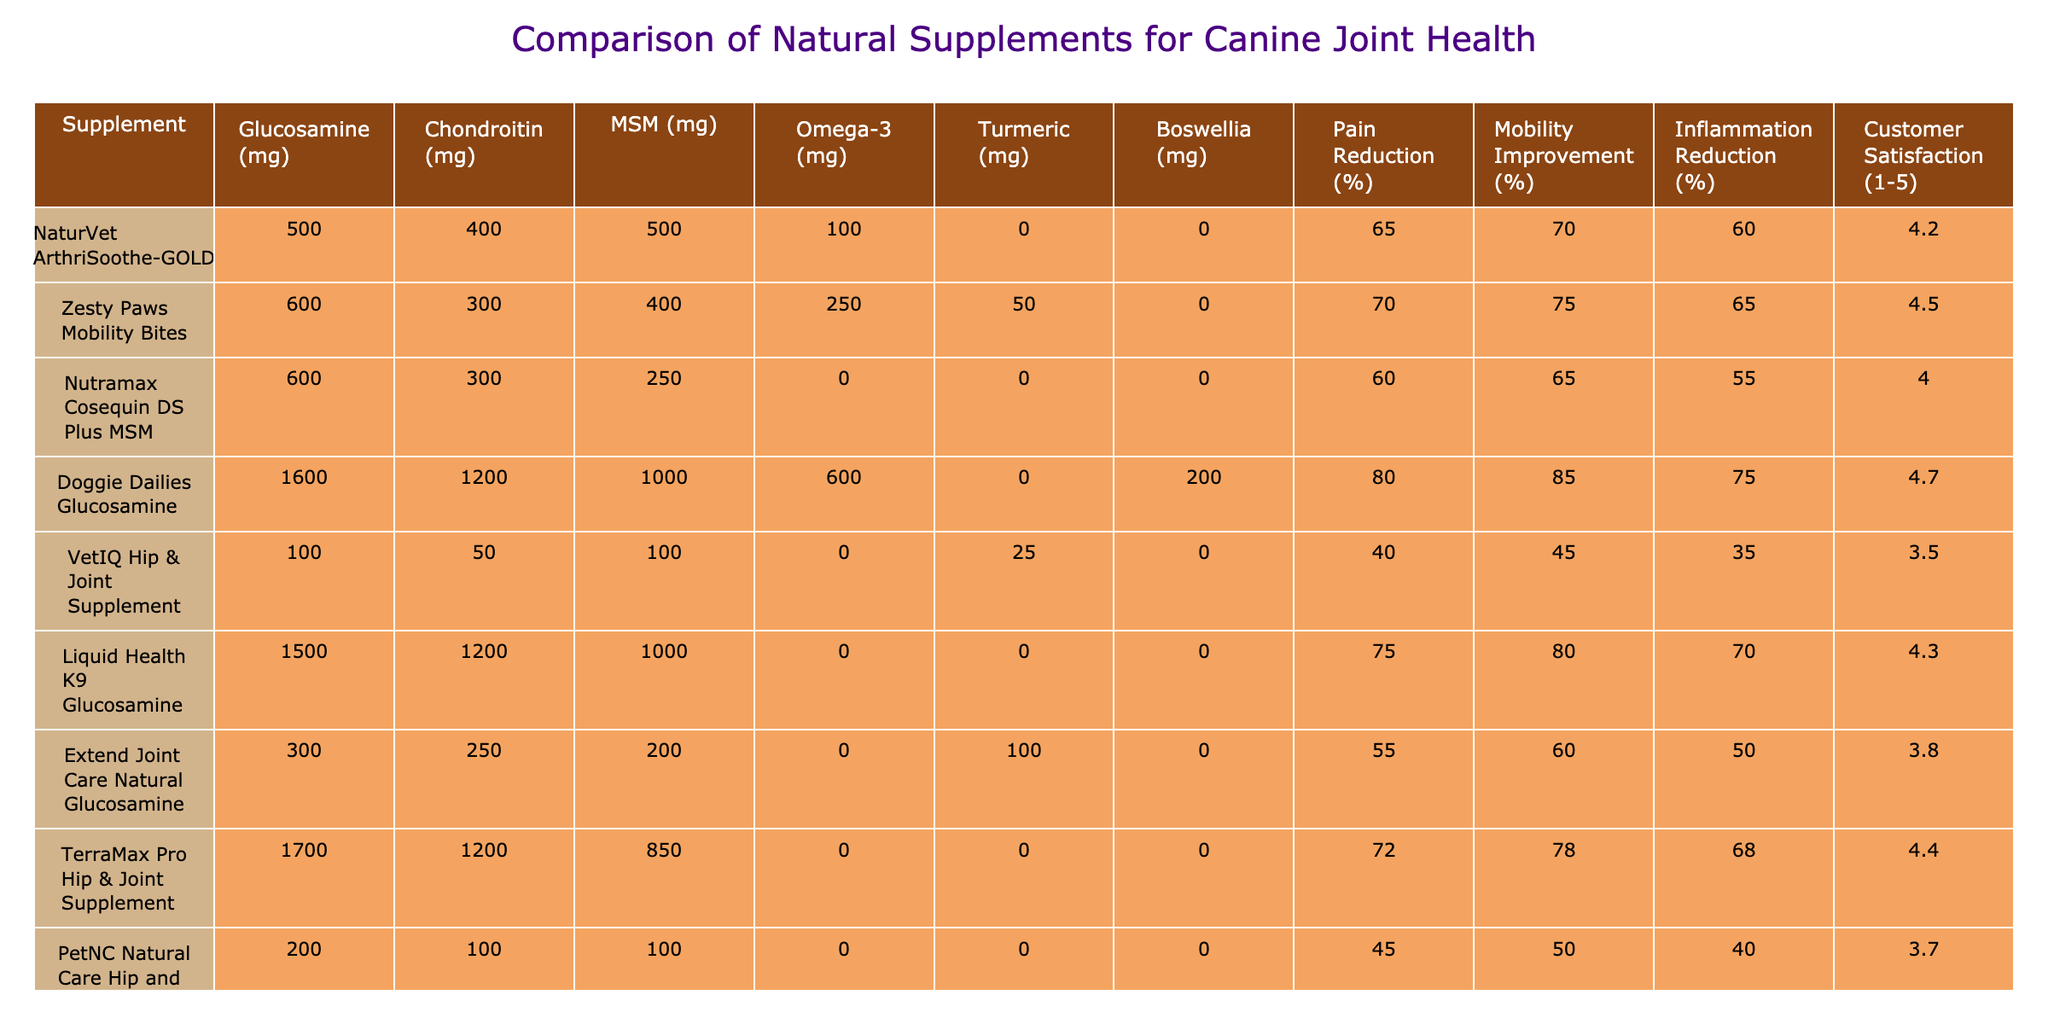What is the customer satisfaction score for Doggie Dailies Glucosamine? The table lists Doggie Dailies Glucosamine under the supplements, with its corresponding customer satisfaction score found in the last column. The score is 4.7.
Answer: 4.7 Which supplement has the highest pain reduction percentage? Looking at the Pain Reduction percentage column, Doggie Dailies Glucosamine has the highest percentage at 80%.
Answer: 80% What is the total dosage of Omega-3 for Zesty Paws Mobility Bites and Infinite Pet Supplements All-Natural Hip & Joint Supplement combined? Zesty Paws Mobility Bites has an Omega-3 dosage of 250 mg, and Infinite Pet Supplements has 300 mg. Adding them together gives 250 + 300 = 550 mg.
Answer: 550 mg Is it true that VetIQ Hip & Joint Supplement has more Chondroitin than NaturVet ArthriSoothe-GOLD? Evaluating the values in the Chondroitin column, VetIQ Hip & Joint Supplement contains 50 mg while NaturVet ArthriSoothe-GOLD has 400 mg, making the statement false.
Answer: No What is the average customer satisfaction score for the top three supplements based on their effectiveness in pain reduction? The top three in pain reduction are Doggie Dailies Glucosamine (80%), Infinite Pet Supplements (78%), and Zesty Paws Mobility Bites (70%). Their customer satisfaction scores are 4.7, 4.6, and 4.5. The average score is (4.7 + 4.6 + 4.5) / 3 = 4.6.
Answer: 4.6 Which supplement shows the lowest improvement in mobility? The Mobility Improvement percentage for PetNC Natural Care Hip and Joint Soft Chews is the lowest at 50%.
Answer: 50% How much MSM is in Nutramax Cosequin DS Plus MSM compared to TerraMax Pro Hip & Joint Supplement? Nutramax Cosequin DS Plus MSM contains 250 mg of MSM, while TerraMax Pro Hip & Joint Supplement contains 850 mg. 850 mg - 250 mg = 600 mg difference.
Answer: 600 mg Which supplement provides the highest amount of Turmeric? Checking the Turmeric column reveals that Infinite Pet Supplements All-Natural Hip & Joint Supplement has the most Turmeric at 150 mg.
Answer: 150 mg If you add the total Pain Reduction percentages of Liquid Health K9 Glucosamine and Extend Joint Care Natural Glucosamine, what do you get? The Pain Reduction percentages are 75% for Liquid Health K9 Glucosamine and 55% for Extend Joint Care Natural Glucosamine. Adding these gives 75 + 55 = 130%.
Answer: 130% Does any supplement offer both Omega-3 and Turmeric? In the table, Zesty Paws Mobility Bites has Omega-3 (250 mg) and Turmeric (50 mg), thus making the statement true.
Answer: Yes What is the difference in Inflammation Reduction between the supplement with the highest and the lowest score? Doggie Dailies Glucosamine has the highest Inflammation Reduction at 75%, while VetIQ Hip & Joint Supplement has the lowest at 35%. The difference is 75% - 35% = 40%.
Answer: 40% 